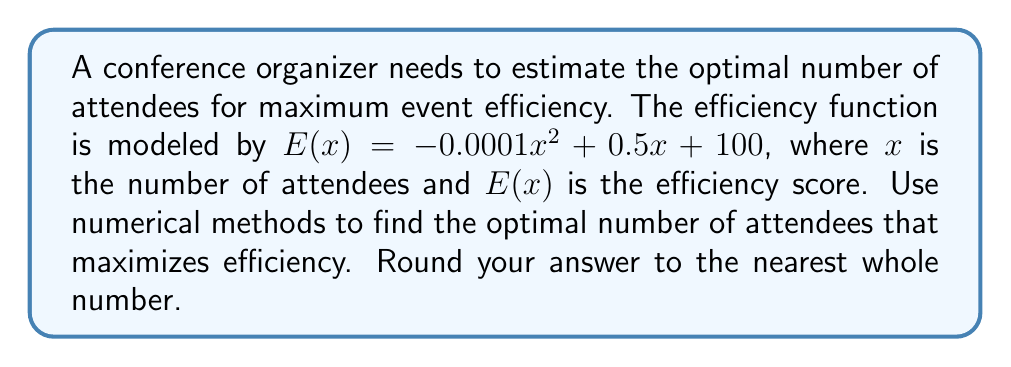Show me your answer to this math problem. To find the optimal number of attendees, we need to maximize the efficiency function $E(x)$. This can be done by finding the critical point where the derivative of $E(x)$ equals zero.

Step 1: Find the derivative of $E(x)$
$$E'(x) = -0.0002x + 0.5$$

Step 2: Set the derivative equal to zero and solve for x
$$-0.0002x + 0.5 = 0$$
$$-0.0002x = -0.5$$
$$x = \frac{-0.5}{-0.0002} = 2500$$

Step 3: Verify that this is a maximum by checking the second derivative
$$E''(x) = -0.0002$$
Since $E''(x)$ is negative, the critical point is a maximum.

Step 4: Round to the nearest whole number
The optimal number of attendees is 2500, which is already a whole number.

Step 5: Calculate the maximum efficiency
$$E(2500) = -0.0001(2500)^2 + 0.5(2500) + 100 = 725$$

Therefore, the optimal number of attendees for maximum event efficiency is 2500, with a maximum efficiency score of 725.
Answer: 2500 